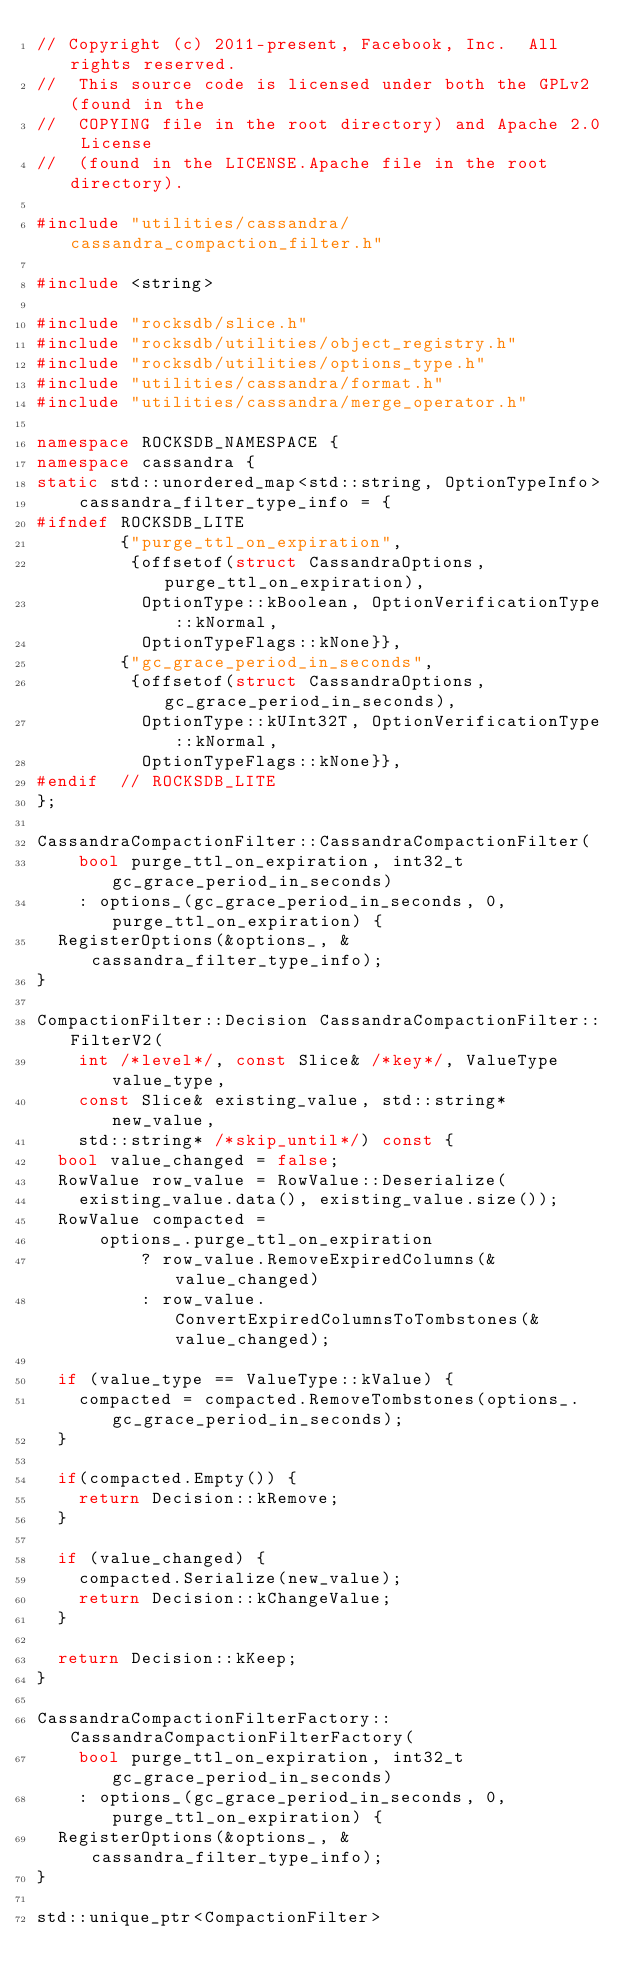<code> <loc_0><loc_0><loc_500><loc_500><_C++_>// Copyright (c) 2011-present, Facebook, Inc.  All rights reserved.
//  This source code is licensed under both the GPLv2 (found in the
//  COPYING file in the root directory) and Apache 2.0 License
//  (found in the LICENSE.Apache file in the root directory).

#include "utilities/cassandra/cassandra_compaction_filter.h"

#include <string>

#include "rocksdb/slice.h"
#include "rocksdb/utilities/object_registry.h"
#include "rocksdb/utilities/options_type.h"
#include "utilities/cassandra/format.h"
#include "utilities/cassandra/merge_operator.h"

namespace ROCKSDB_NAMESPACE {
namespace cassandra {
static std::unordered_map<std::string, OptionTypeInfo>
    cassandra_filter_type_info = {
#ifndef ROCKSDB_LITE
        {"purge_ttl_on_expiration",
         {offsetof(struct CassandraOptions, purge_ttl_on_expiration),
          OptionType::kBoolean, OptionVerificationType::kNormal,
          OptionTypeFlags::kNone}},
        {"gc_grace_period_in_seconds",
         {offsetof(struct CassandraOptions, gc_grace_period_in_seconds),
          OptionType::kUInt32T, OptionVerificationType::kNormal,
          OptionTypeFlags::kNone}},
#endif  // ROCKSDB_LITE
};

CassandraCompactionFilter::CassandraCompactionFilter(
    bool purge_ttl_on_expiration, int32_t gc_grace_period_in_seconds)
    : options_(gc_grace_period_in_seconds, 0, purge_ttl_on_expiration) {
  RegisterOptions(&options_, &cassandra_filter_type_info);
}

CompactionFilter::Decision CassandraCompactionFilter::FilterV2(
    int /*level*/, const Slice& /*key*/, ValueType value_type,
    const Slice& existing_value, std::string* new_value,
    std::string* /*skip_until*/) const {
  bool value_changed = false;
  RowValue row_value = RowValue::Deserialize(
    existing_value.data(), existing_value.size());
  RowValue compacted =
      options_.purge_ttl_on_expiration
          ? row_value.RemoveExpiredColumns(&value_changed)
          : row_value.ConvertExpiredColumnsToTombstones(&value_changed);

  if (value_type == ValueType::kValue) {
    compacted = compacted.RemoveTombstones(options_.gc_grace_period_in_seconds);
  }

  if(compacted.Empty()) {
    return Decision::kRemove;
  }

  if (value_changed) {
    compacted.Serialize(new_value);
    return Decision::kChangeValue;
  }

  return Decision::kKeep;
}

CassandraCompactionFilterFactory::CassandraCompactionFilterFactory(
    bool purge_ttl_on_expiration, int32_t gc_grace_period_in_seconds)
    : options_(gc_grace_period_in_seconds, 0, purge_ttl_on_expiration) {
  RegisterOptions(&options_, &cassandra_filter_type_info);
}

std::unique_ptr<CompactionFilter></code> 